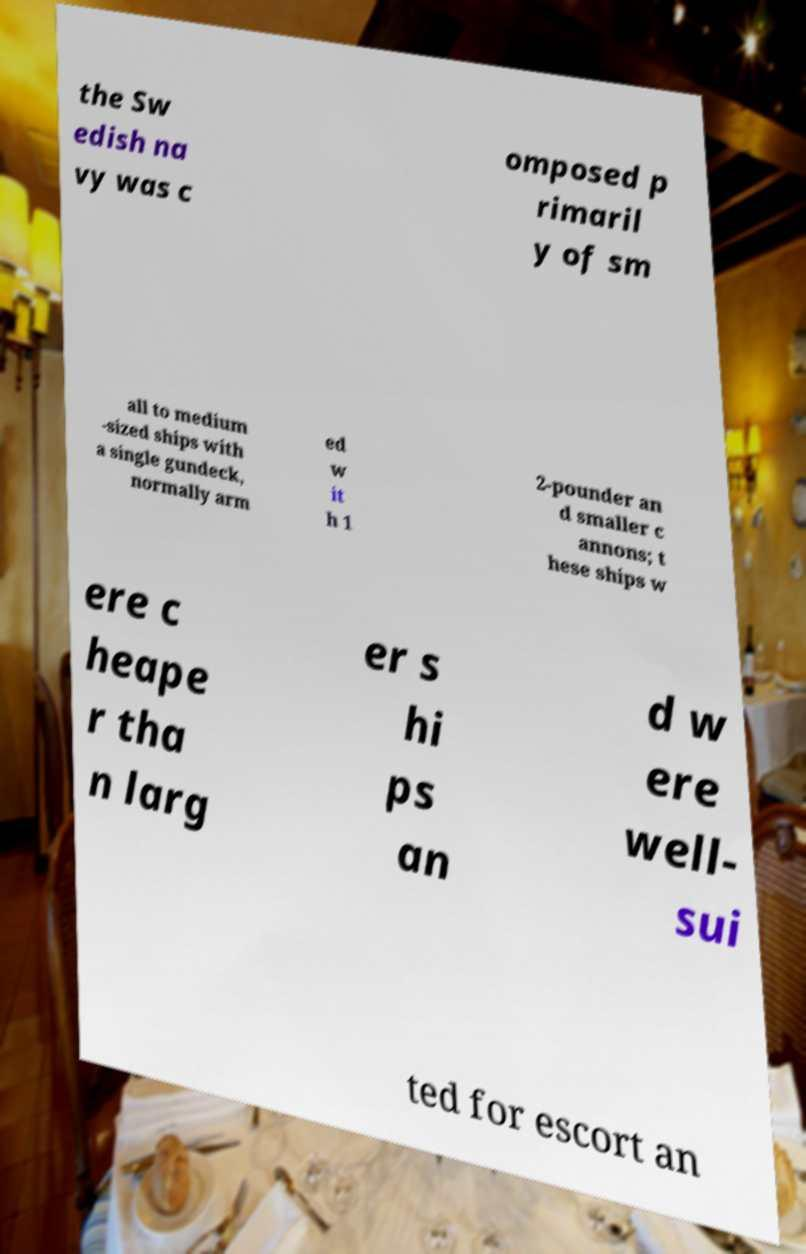What messages or text are displayed in this image? I need them in a readable, typed format. the Sw edish na vy was c omposed p rimaril y of sm all to medium -sized ships with a single gundeck, normally arm ed w it h 1 2-pounder an d smaller c annons; t hese ships w ere c heape r tha n larg er s hi ps an d w ere well- sui ted for escort an 